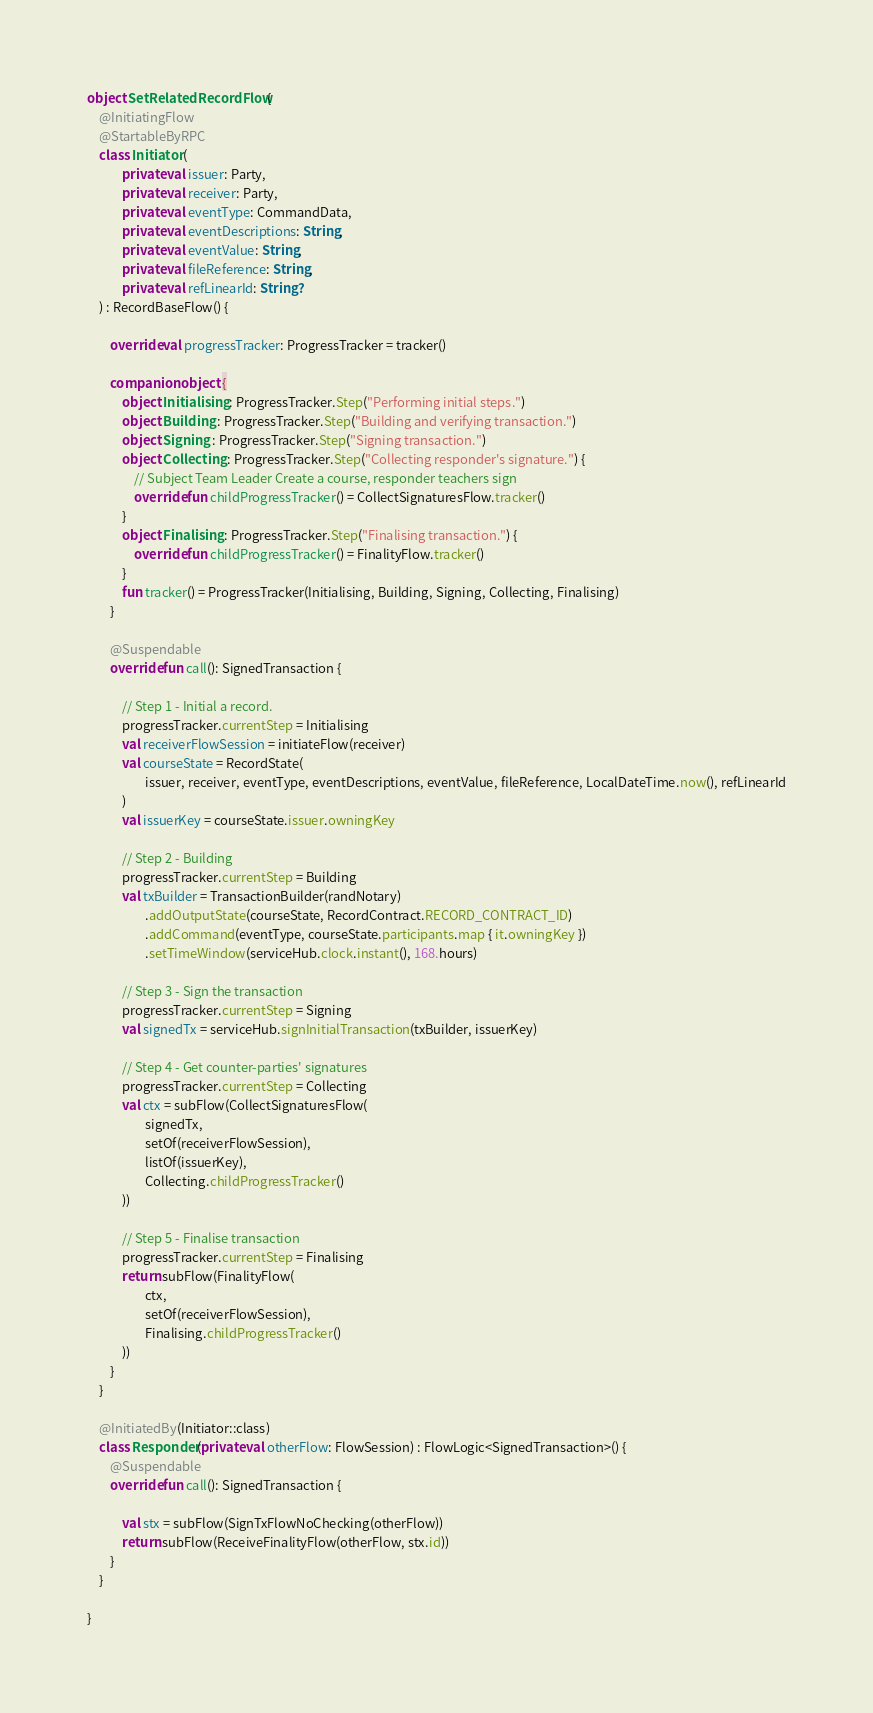<code> <loc_0><loc_0><loc_500><loc_500><_Kotlin_>object SetRelatedRecordFlow {
    @InitiatingFlow
    @StartableByRPC
    class Initiator (
            private val issuer: Party,
            private val receiver: Party,
            private val eventType: CommandData,
            private val eventDescriptions: String,
            private val eventValue: String,
            private val fileReference: String,
            private val refLinearId: String?
    ) : RecordBaseFlow() {

        override val progressTracker: ProgressTracker = tracker()

        companion object {
            object Initialising : ProgressTracker.Step("Performing initial steps.")
            object Building : ProgressTracker.Step("Building and verifying transaction.")
            object Signing : ProgressTracker.Step("Signing transaction.")
            object Collecting : ProgressTracker.Step("Collecting responder's signature.") {
                // Subject Team Leader Create a course, responder teachers sign
                override fun childProgressTracker() = CollectSignaturesFlow.tracker()
            }
            object Finalising : ProgressTracker.Step("Finalising transaction.") {
                override fun childProgressTracker() = FinalityFlow.tracker()
            }
            fun tracker() = ProgressTracker(Initialising, Building, Signing, Collecting, Finalising)
        }

        @Suspendable
        override fun call(): SignedTransaction {

            // Step 1 - Initial a record.
            progressTracker.currentStep = Initialising
            val receiverFlowSession = initiateFlow(receiver)
            val courseState = RecordState(
                    issuer, receiver, eventType, eventDescriptions, eventValue, fileReference, LocalDateTime.now(), refLinearId
            )
            val issuerKey = courseState.issuer.owningKey

            // Step 2 - Building
            progressTracker.currentStep = Building
            val txBuilder = TransactionBuilder(randNotary)
                    .addOutputState(courseState, RecordContract.RECORD_CONTRACT_ID)
                    .addCommand(eventType, courseState.participants.map { it.owningKey })
                    .setTimeWindow(serviceHub.clock.instant(), 168.hours)

            // Step 3 - Sign the transaction
            progressTracker.currentStep = Signing
            val signedTx = serviceHub.signInitialTransaction(txBuilder, issuerKey)

            // Step 4 - Get counter-parties' signatures
            progressTracker.currentStep = Collecting
            val ctx = subFlow(CollectSignaturesFlow(
                    signedTx,
                    setOf(receiverFlowSession),
                    listOf(issuerKey),
                    Collecting.childProgressTracker()
            ))

            // Step 5 - Finalise transaction
            progressTracker.currentStep = Finalising
            return subFlow(FinalityFlow(
                    ctx,
                    setOf(receiverFlowSession),
                    Finalising.childProgressTracker()
            ))
        }
    }

    @InitiatedBy(Initiator::class)
    class Responder(private val otherFlow: FlowSession) : FlowLogic<SignedTransaction>() {
        @Suspendable
        override fun call(): SignedTransaction {

            val stx = subFlow(SignTxFlowNoChecking(otherFlow))
            return subFlow(ReceiveFinalityFlow(otherFlow, stx.id))
        }
    }

}</code> 